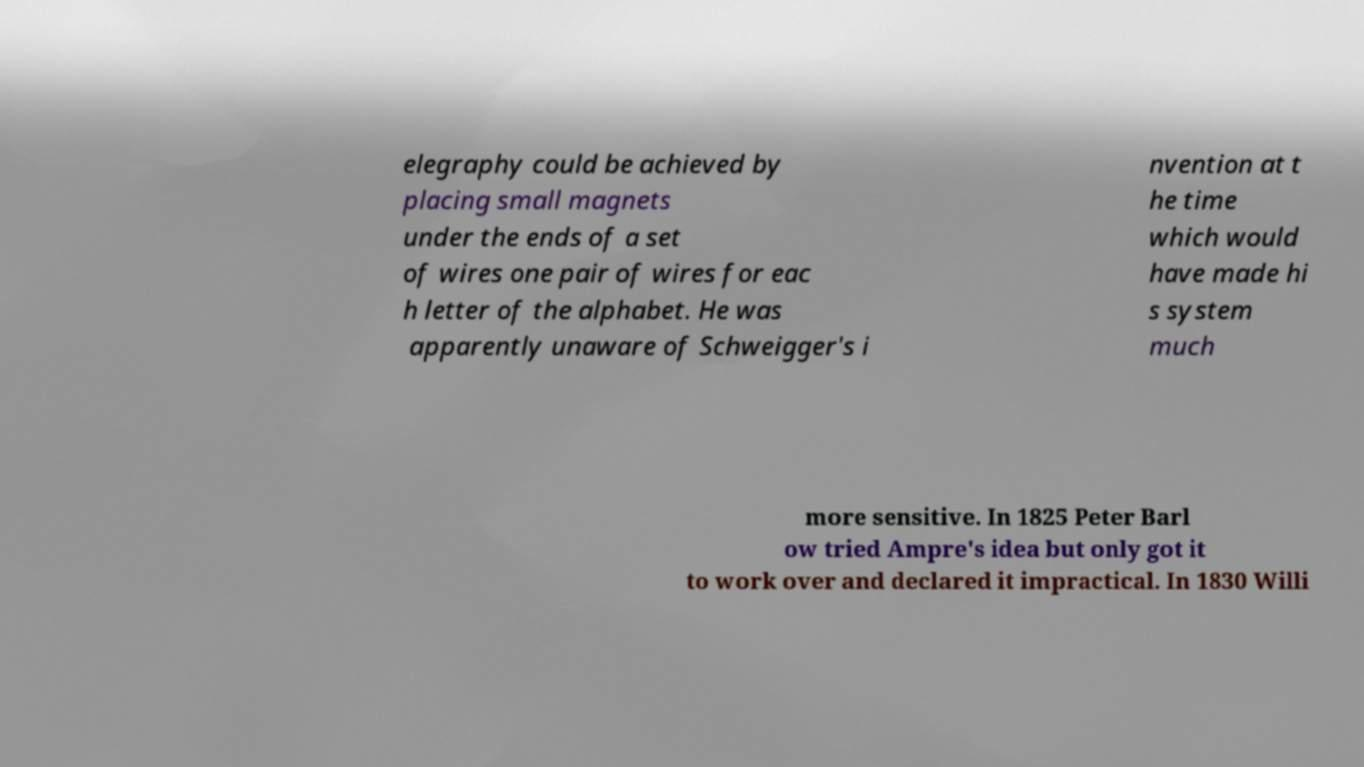Can you accurately transcribe the text from the provided image for me? elegraphy could be achieved by placing small magnets under the ends of a set of wires one pair of wires for eac h letter of the alphabet. He was apparently unaware of Schweigger's i nvention at t he time which would have made hi s system much more sensitive. In 1825 Peter Barl ow tried Ampre's idea but only got it to work over and declared it impractical. In 1830 Willi 